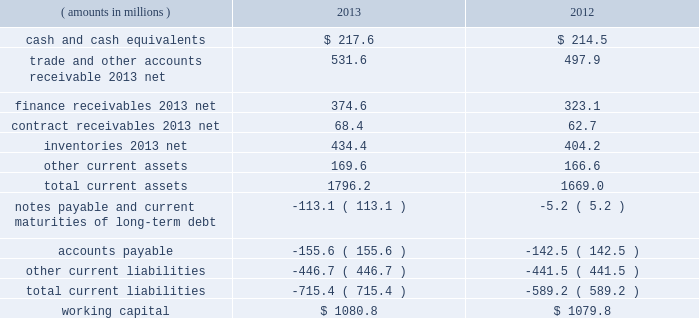Management 2019s discussion and analysis of financial condition and results of operations ( continued ) liquidity and capital resources snap-on 2019s growth has historically been funded by a combination of cash provided by operating activities and debt financing .
Snap-on believes that its cash from operations and collections of finance receivables , coupled with its sources of borrowings and available cash on hand , are sufficient to fund its currently anticipated requirements for scheduled debt payments ( including the march 2014 repayment of $ 100.0 million of 5.85% ( 5.85 % ) unsecured notes upon maturity ) , payments of interest and dividends , new receivables originated by our financial services businesses , capital expenditures , working capital , restructuring activities , the funding of pension plans , and funding for additional share repurchases and acquisitions , if any .
Due to snap-on 2019s credit rating over the years , external funds have been available at an acceptable cost .
As of the close of business on february 7 , 2014 , snap-on 2019s long-term debt and commercial paper were rated , respectively , a3 and p-2 by moody 2019s investors service ; a- and a-2 by standard & poor 2019s ; and a- and f2 by fitch ratings .
Snap-on believes that its current credit arrangements are sound and that the strength of its balance sheet affords the company the financial flexibility to respond to both internal growth opportunities and those available through acquisitions .
However , snap-on cannot provide any assurances of the availability of future financing or the terms on which it might be available , or that its debt ratings may not decrease .
The following discussion focuses on information included in the accompanying consolidated balance sheets .
As of 2013 year end , working capital ( current assets less current liabilities ) of $ 1080.8 million increased $ 1.0 million from $ 1079.8 million as of 2012 year end .
The following represents the company 2019s working capital position as of 2013 and 2012 year end : ( amounts in millions ) 2013 2012 .
Cash and cash equivalents of $ 217.6 million as of 2013 year end compared to cash and cash equivalents of $ 214.5 million at 2012 year end .
The $ 3.1 million net increase in cash and cash equivalents includes the impacts of ( i ) $ 508.8 million of cash from collections of finance receivables ; ( ii ) $ 392.6 million of cash generated from operations , net of $ 24.3 million of discretionary cash contributions to the company 2019s pension plans ; ( iii ) $ 29.2 million of cash proceeds from stock purchase and option plan exercises ; and ( iv ) $ 8.4 million of cash proceeds from the sale of property and equipment .
These increases in cash and cash equivalents were largely offset by ( i ) the funding of $ 651.3 million of new finance receivables ; ( ii ) dividend payments to shareholders of $ 92.0 million ; ( iii ) the repurchase of 926000 shares of the company 2019s common stock for $ 82.6 million ; ( iv ) the funding of $ 70.6 million of capital expenditures ; and ( v ) the may 2013 acquisition of challenger for a cash purchase price of $ 38.2 million .
Of the $ 217.6 million of cash and cash equivalents as of 2013 year end , $ 124.3 million was held outside of the united states .
Snap-on considers these non-u.s .
Funds as permanently invested in its foreign operations to ( i ) provide adequate working capital ; ( ii ) satisfy various regulatory requirements ; and/or ( iii ) take advantage of business expansion opportunities as they arise ; as such , the company does not presently expect to repatriate these funds to fund its u.s .
Operations or obligations .
The repatriation of cash from certain foreign subsidiaries could have adverse net tax consequences on the company should snap-on be required to pay and record u.s .
Income taxes and foreign withholding taxes on funds that were previously considered permanently invested .
Alternatively , the repatriation of such cash from certain other foreign subsidiaries could result in favorable net tax consequences for the company .
Snap-on periodically evaluates opportunities to repatriate certain foreign cash amounts to the extent that it does not incur additional unfavorable net tax consequences .
46 snap-on incorporated .
What is the percentage change in the balance of inventories from 2012 to 2013? 
Computations: ((434.4 - 404.2) / 404.2)
Answer: 0.07472. 